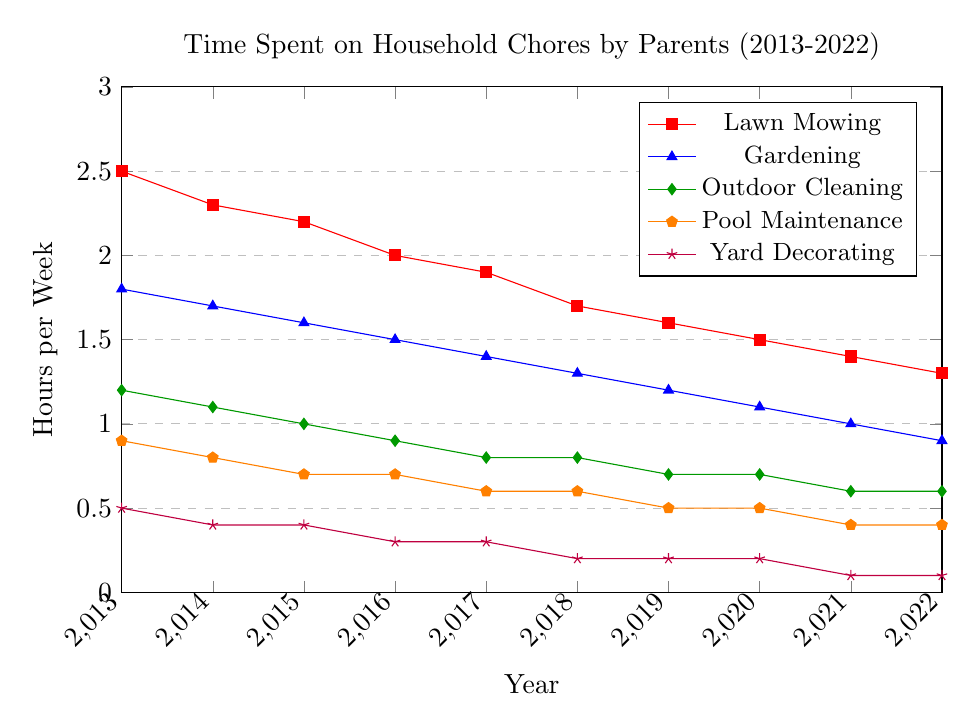What is the average time spent on Lawn Mowing over the decade? To find the average time spent on Lawn Mowing over the decade, sum up the values from 2013 to 2022 and then divide by the number of years (10). (2.5 + 2.3 + 2.2 + 2.0 + 1.9 + 1.7 + 1.6 + 1.5 + 1.4 + 1.3) / 10 = 18.4 / 10 = 1.84
Answer: 1.84 Between Gardening and Outdoor Cleaning, which task saw a larger decrease in the hours spent from 2013 to 2022? Calculate the difference in hours spent between 2013 and 2022 for both tasks. Gardening: 1.8 - 0.9 = 0.9; Outdoor Cleaning: 1.2 - 0.6 = 0.6. Gardening saw a larger decrease.
Answer: Gardening In which year did Pool Maintenance hours remain constant compared to the previous year? Check the data for years where the value for Pool Maintenance hours is the same as the previous year. This occurs between 2015 and 2016, as well as between 2019 and 2020.
Answer: 2016, 2020 What is the smallest amount of time spent on Yard Decorating in any given year? Observe the data and identify the smallest value in Yard Decorating column, which is in 2021 and 2022.
Answer: 0.1 By how much did the time spent on Lawn Mowing reduce from 2013 to 2022? Subtract the Lawn Mowing time in 2022 from the time in 2013. 2.5 - 1.3 = 1.2.
Answer: 1.2 Which task consistently had the lowest weekly hours over the entire period? Examine the chart and identify the task with consistently the lowest values over the displayed years. Yard Decorating has the smallest values throughout 2013-2022.
Answer: Yard Decorating Considering the time spent on Outdoor Cleaning and Lawn Mowing, how much more time was spent on Lawn Mowing in 2015? Look at the values for Lawn Mowing and Outdoor Cleaning in 2015. Lawn Mowing: 2.2; Outdoor Cleaning: 1.0. The difference is 2.2 - 1.0 = 1.2.
Answer: 1.2 What's the overall trend for time spent on Gardening from 2013 to 2022? Observe the general direction of the line plot for Gardening; it shows a consistently decreasing trend.
Answer: Decreasing In 2013, how much more time was spent on Lawn Mowing compared to Pool Maintenance? Subtract the time spent on Pool Maintenance from the time spent on Lawn Mowing in 2013. 2.5 - 0.9 = 1.6.
Answer: 1.6 Which year shows the first significant decrease in time spent on Yard Decorating? Observe the data points for Yard Decorating and identify the year where the values drop significantly for the first time. It decreases notably from 2016 (0.3) to 2017 (0.3).
Answer: 2016 